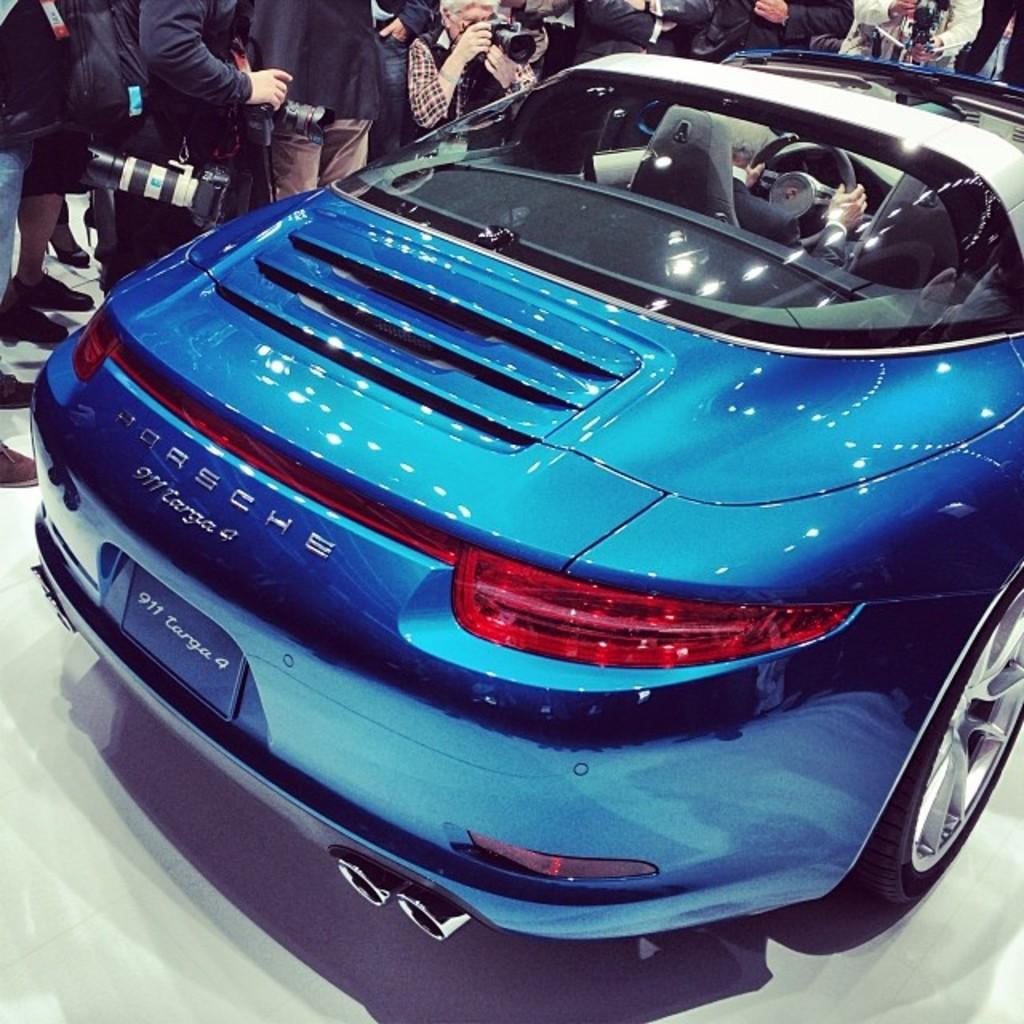How many people are in the image? There is a group of people in the image. What else can be seen in the image besides the people? There is a car in the image, and a person is seated in the car. What objects are related to capturing images in the scene? There are cameras visible in the image. What type of table is present in the image? There is no table present in the image. What boundary is visible in the image? There is no boundary visible in the image. 